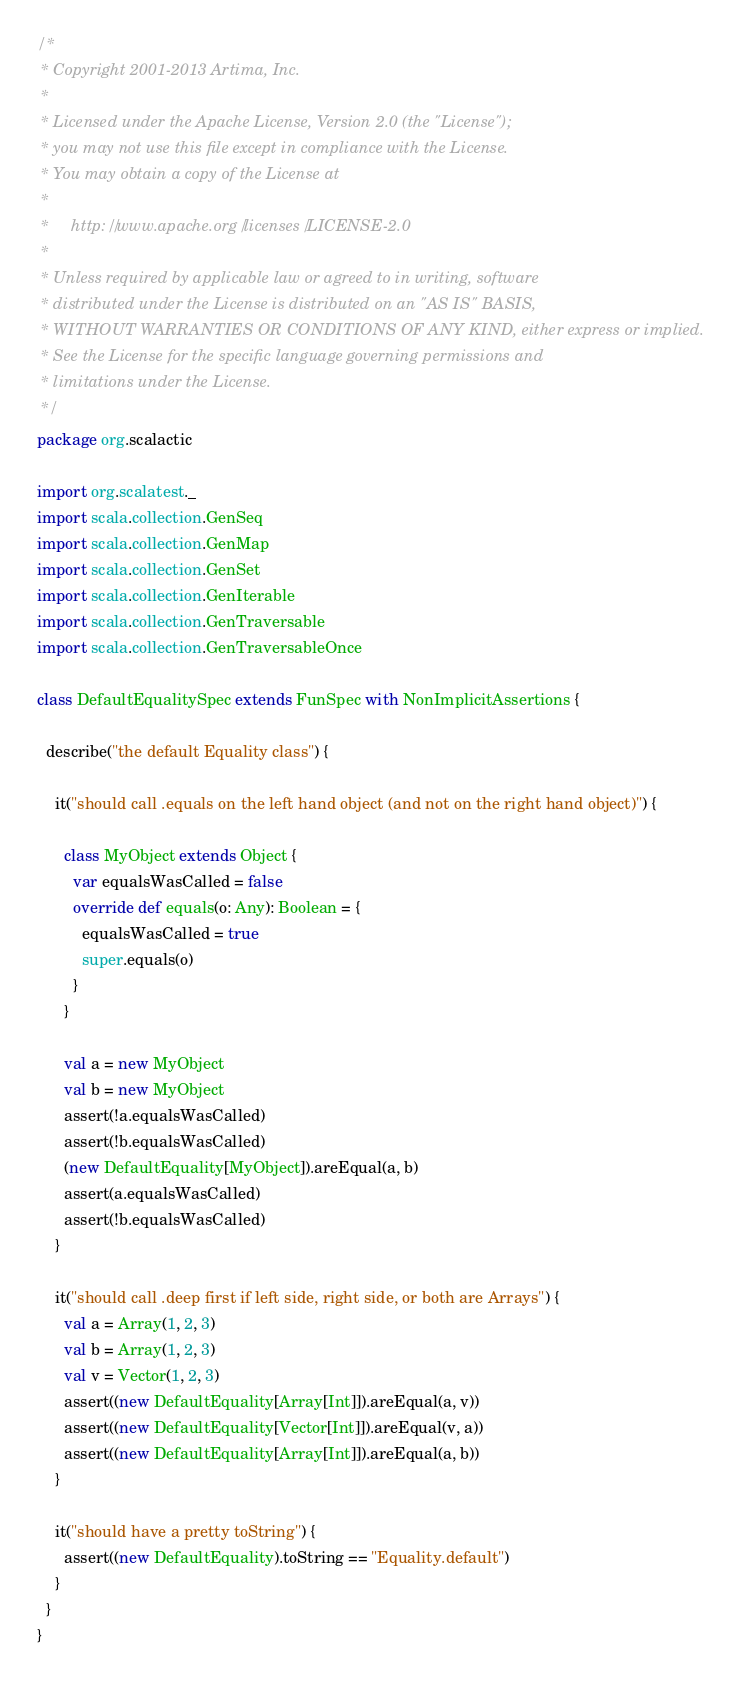<code> <loc_0><loc_0><loc_500><loc_500><_Scala_>/*
 * Copyright 2001-2013 Artima, Inc.
 *
 * Licensed under the Apache License, Version 2.0 (the "License");
 * you may not use this file except in compliance with the License.
 * You may obtain a copy of the License at
 *
 *     http://www.apache.org/licenses/LICENSE-2.0
 *
 * Unless required by applicable law or agreed to in writing, software
 * distributed under the License is distributed on an "AS IS" BASIS,
 * WITHOUT WARRANTIES OR CONDITIONS OF ANY KIND, either express or implied.
 * See the License for the specific language governing permissions and
 * limitations under the License.
 */
package org.scalactic

import org.scalatest._
import scala.collection.GenSeq
import scala.collection.GenMap
import scala.collection.GenSet
import scala.collection.GenIterable
import scala.collection.GenTraversable
import scala.collection.GenTraversableOnce

class DefaultEqualitySpec extends FunSpec with NonImplicitAssertions {

  describe("the default Equality class") {

    it("should call .equals on the left hand object (and not on the right hand object)") {

      class MyObject extends Object {
        var equalsWasCalled = false
        override def equals(o: Any): Boolean = {
          equalsWasCalled = true
          super.equals(o)
        }
      }

      val a = new MyObject
      val b = new MyObject
      assert(!a.equalsWasCalled)
      assert(!b.equalsWasCalled)
      (new DefaultEquality[MyObject]).areEqual(a, b)
      assert(a.equalsWasCalled)
      assert(!b.equalsWasCalled)
    }

    it("should call .deep first if left side, right side, or both are Arrays") {
      val a = Array(1, 2, 3)
      val b = Array(1, 2, 3)
      val v = Vector(1, 2, 3)
      assert((new DefaultEquality[Array[Int]]).areEqual(a, v))
      assert((new DefaultEquality[Vector[Int]]).areEqual(v, a))
      assert((new DefaultEquality[Array[Int]]).areEqual(a, b))
    }

    it("should have a pretty toString") {
      assert((new DefaultEquality).toString == "Equality.default")
    }
  }
}

</code> 